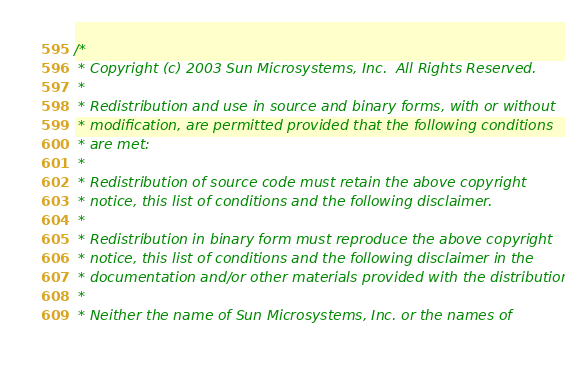<code> <loc_0><loc_0><loc_500><loc_500><_C_>/*
 * Copyright (c) 2003 Sun Microsystems, Inc.  All Rights Reserved.
 * 
 * Redistribution and use in source and binary forms, with or without
 * modification, are permitted provided that the following conditions
 * are met:
 * 
 * Redistribution of source code must retain the above copyright
 * notice, this list of conditions and the following disclaimer.
 * 
 * Redistribution in binary form must reproduce the above copyright
 * notice, this list of conditions and the following disclaimer in the
 * documentation and/or other materials provided with the distribution.
 * 
 * Neither the name of Sun Microsystems, Inc. or the names of</code> 